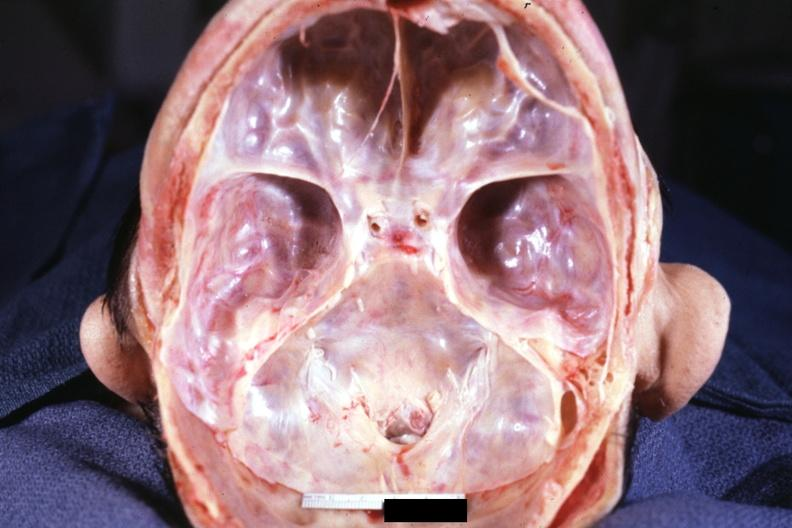s rheumatoid arthritis present?
Answer the question using a single word or phrase. Yes 